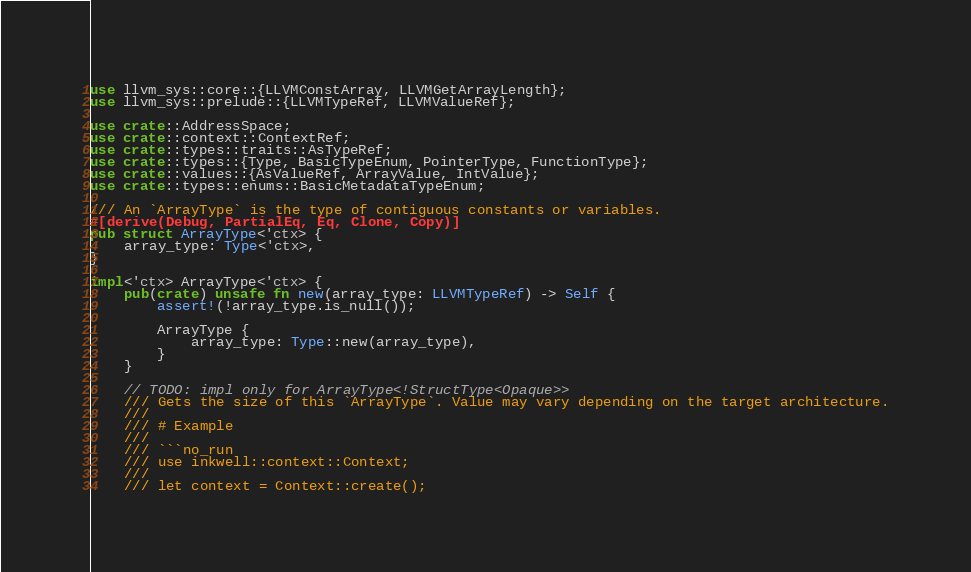<code> <loc_0><loc_0><loc_500><loc_500><_Rust_>use llvm_sys::core::{LLVMConstArray, LLVMGetArrayLength};
use llvm_sys::prelude::{LLVMTypeRef, LLVMValueRef};

use crate::AddressSpace;
use crate::context::ContextRef;
use crate::types::traits::AsTypeRef;
use crate::types::{Type, BasicTypeEnum, PointerType, FunctionType};
use crate::values::{AsValueRef, ArrayValue, IntValue};
use crate::types::enums::BasicMetadataTypeEnum;

/// An `ArrayType` is the type of contiguous constants or variables.
#[derive(Debug, PartialEq, Eq, Clone, Copy)]
pub struct ArrayType<'ctx> {
    array_type: Type<'ctx>,
}

impl<'ctx> ArrayType<'ctx> {
    pub(crate) unsafe fn new(array_type: LLVMTypeRef) -> Self {
        assert!(!array_type.is_null());

        ArrayType {
            array_type: Type::new(array_type),
        }
    }

    // TODO: impl only for ArrayType<!StructType<Opaque>>
    /// Gets the size of this `ArrayType`. Value may vary depending on the target architecture.
    ///
    /// # Example
    ///
    /// ```no_run
    /// use inkwell::context::Context;
    ///
    /// let context = Context::create();</code> 